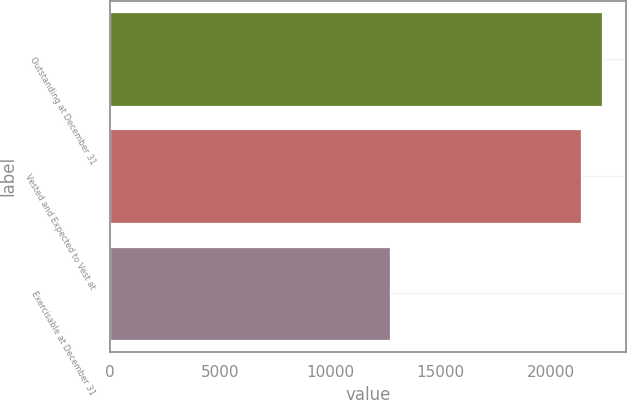Convert chart. <chart><loc_0><loc_0><loc_500><loc_500><bar_chart><fcel>Outstanding at December 31<fcel>Vested and Expected to Vest at<fcel>Exercisable at December 31<nl><fcel>22329.2<fcel>21393<fcel>12722<nl></chart> 